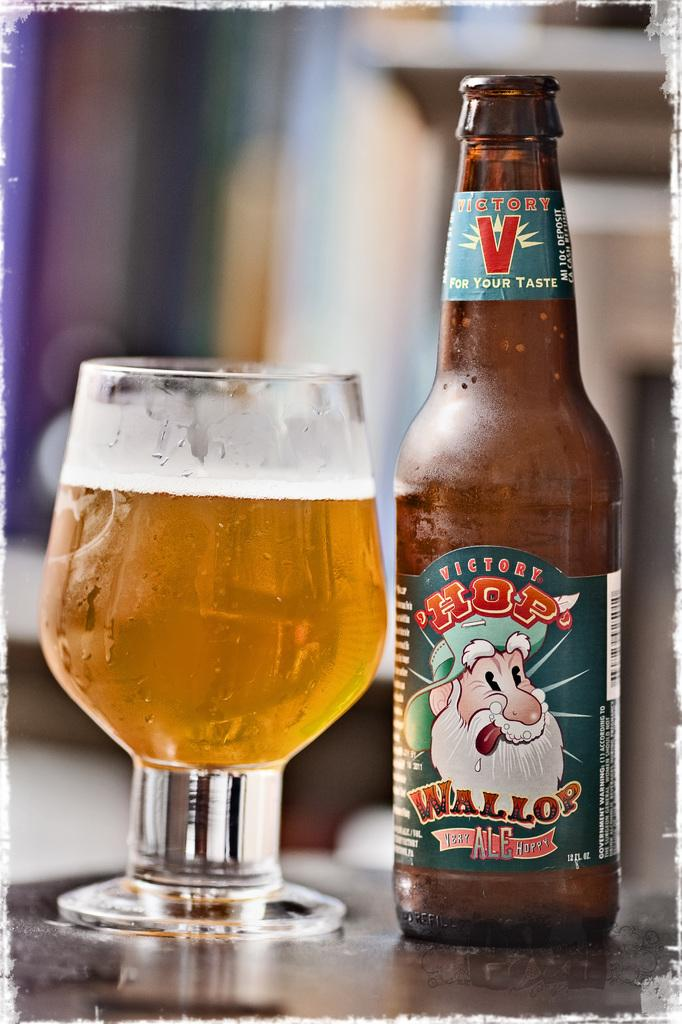What is in the image that can hold a liquid? There is a bottle and a glass with beer in the image. What type of liquid is in the glass? The glass contains beer. What is attached to the bottle? The bottle has a sticker attached to it. What is depicted on the sticker? The sticker features a person with a white beard. How many babies are being supported by the person on the sticker? There are no babies present in the image, and the sticker does not depict anyone supporting babies. 